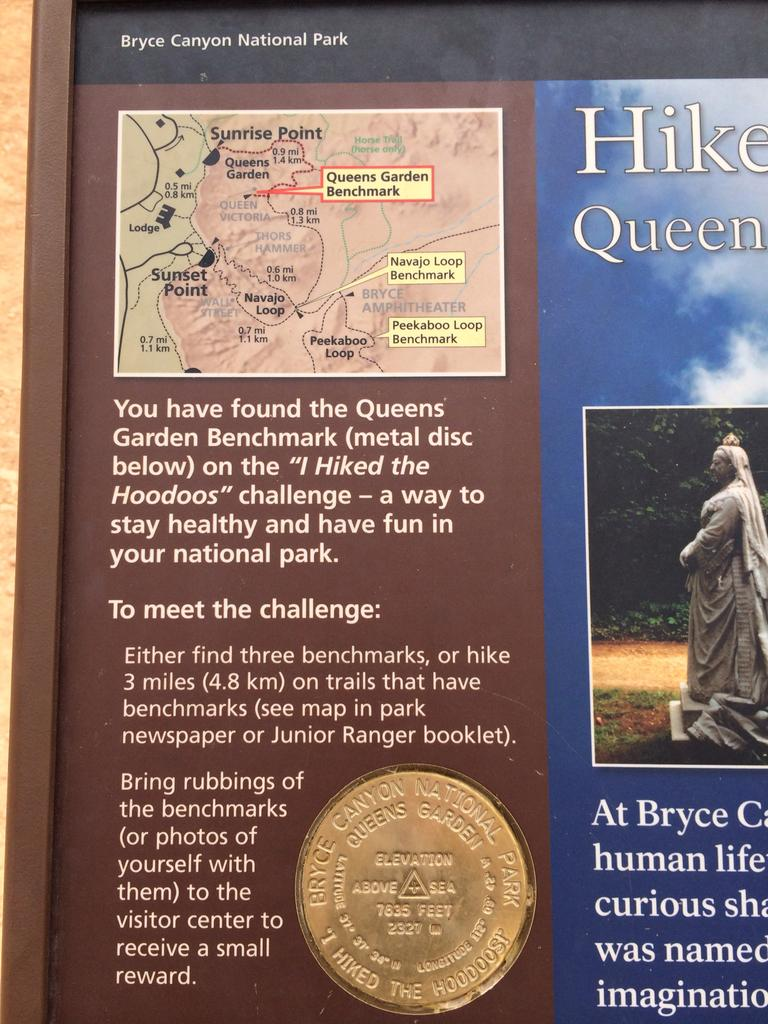<image>
Present a compact description of the photo's key features. A sign with a map of Bryce Canyon National Park in the corner. 